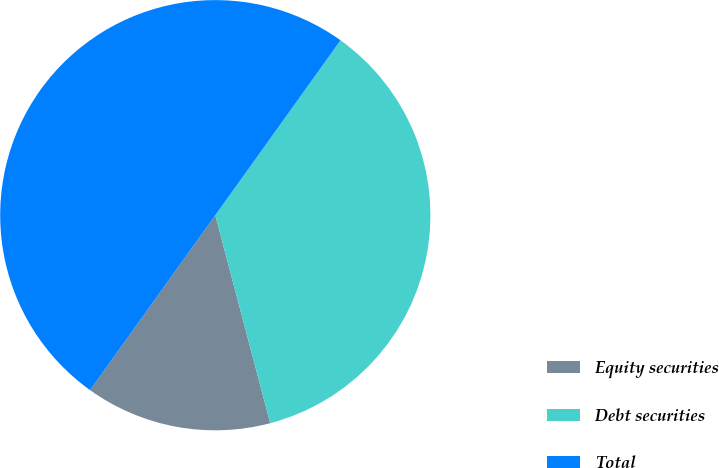Convert chart. <chart><loc_0><loc_0><loc_500><loc_500><pie_chart><fcel>Equity securities<fcel>Debt securities<fcel>Total<nl><fcel>14.0%<fcel>36.0%<fcel>50.0%<nl></chart> 